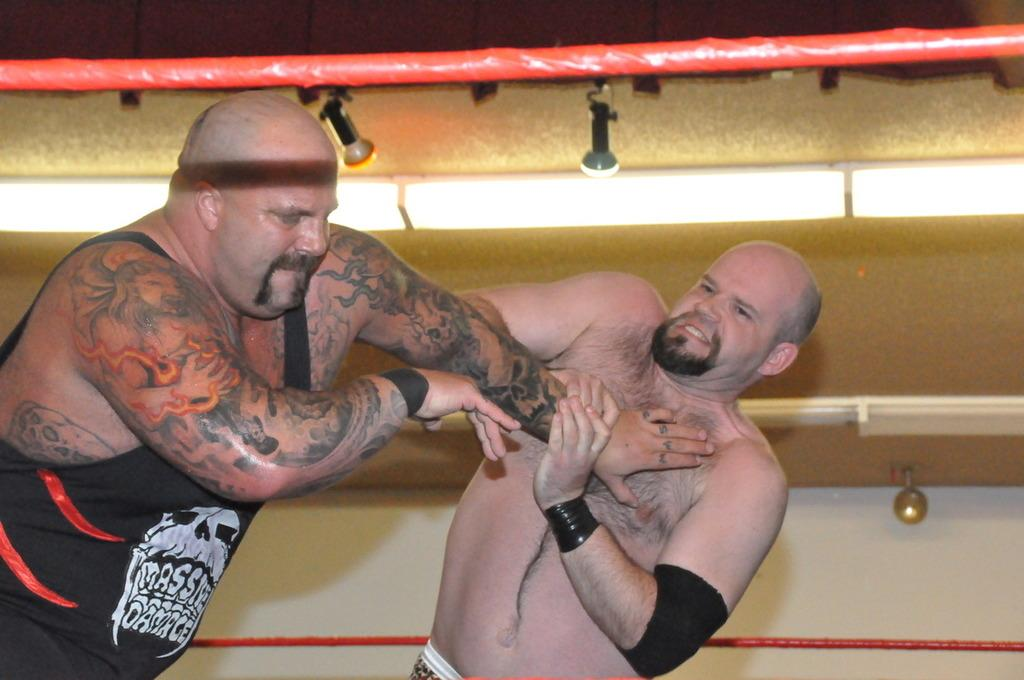How many people are in the image? There are two persons in the image. What are the two persons doing? The two persons appear to be fighting. What can be seen in the background of the image? There is a golden and white color wall in the background. What is the color of the rope at the top of the image? The rope is red in color. How many mailboxes can be seen in the image? There are no mailboxes present in the image. What type of basin is being used by the cats in the image? There are no cats or basins present in the image. 